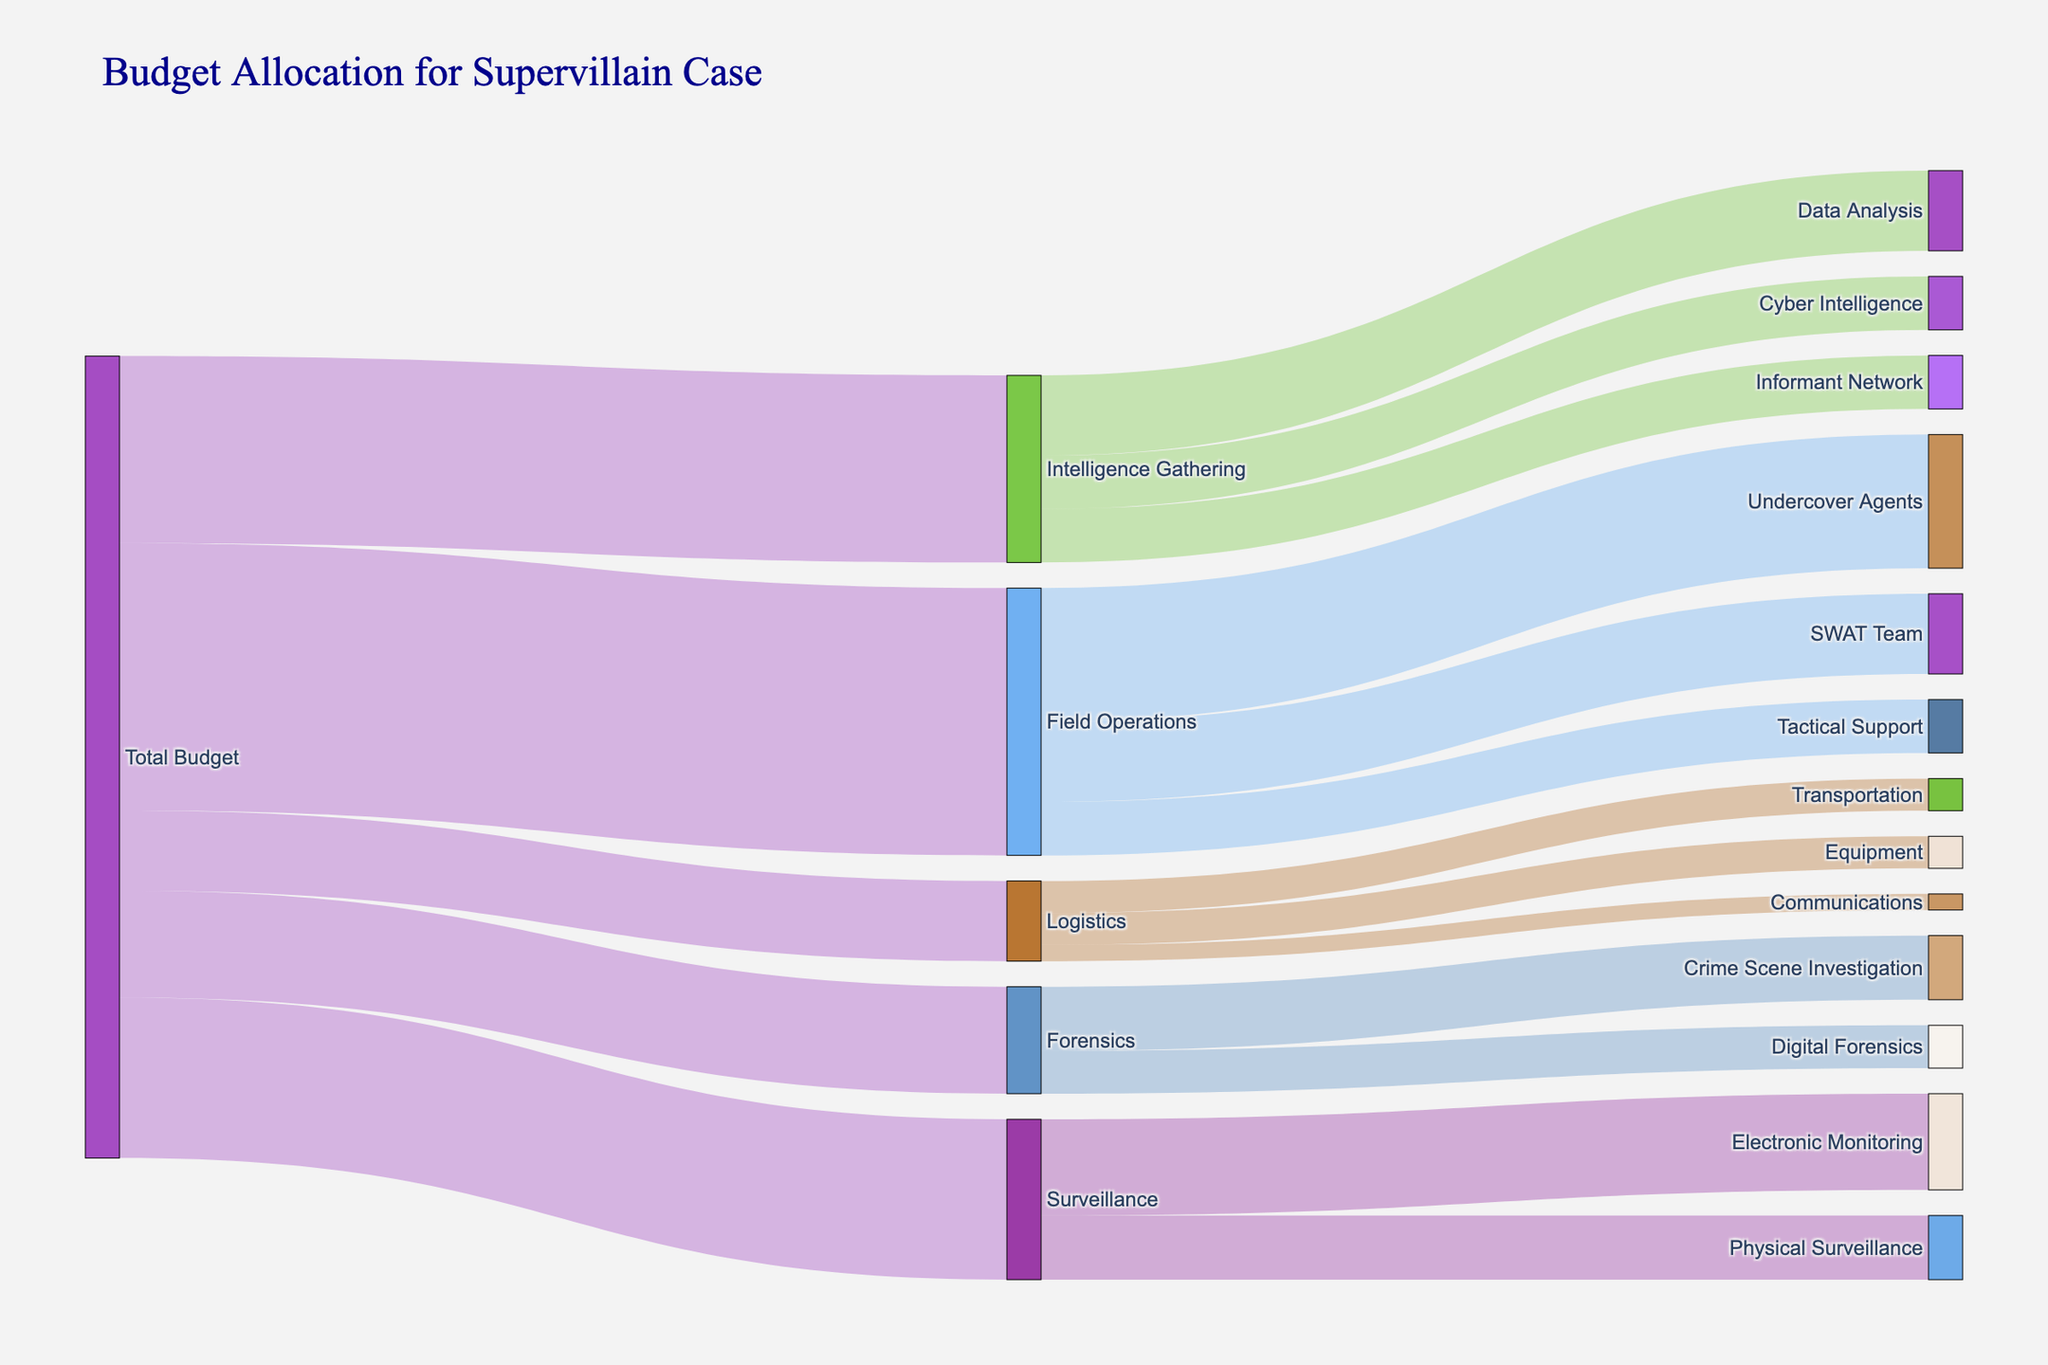What is the title of the Sankey diagram? The title is usually displayed at the top of the figure. According to the code, the title of this Sankey diagram is "Budget Allocation for Supervillain Case".
Answer: Budget Allocation for Supervillain Case What is the total budget allocated to Surveillance? Surveillance is one of the primary target categories originating from the Total Budget node. According to the data provided, Surveillance receives a direct allocation of $3,000,000.
Answer: 3,000,000 Which operation under Field Operations receives the highest budget allocation? Field Operations branches into three categories: Undercover Agents, SWAT Team, and Tactical Support. Comparing their allocations, Undercover Agents receive $2,500,000, which is higher than the other two.
Answer: Undercover Agents How much total budget is allocated to all Forensics-related activities? According to the data, Forensics encompasses Crime Scene Investigation and Digital Forensics. Summing their allocations: $1,200,000 + $800,000, the total budget for Forensics-related activities is $2,000,000.
Answer: 2,000,000 Which unit receives more funding, Cyber Intelligence or Electronic Monitoring? Cyber Intelligence is under Intelligence Gathering and Electronic Monitoring is under Surveillance. Cyber Intelligence receives $1,000,000 while Electronic Monitoring receives $1,800,000. Thus, Electronic Monitoring receives more funding.
Answer: Electronic Monitoring What is the combined budget allocation for both categories under Logistics? Logistics includes Transportation, Equipment, and Communications. Their allocations are $600,000, $600,000, and $300,000 respectively. Summing these allocations gives: $600,000 + $600,000 + $300,000 = $1,500,000.
Answer: 1,500,000 How does the budget allocation for Informant Network compare to that for Crime Scene Investigation? Informant Network under Intelligence Gathering is allocated $1,000,000. In contrast, Crime Scene Investigation under Forensics is allocated $1,200,000. Thus, Crime Scene Investigation receives more funding.
Answer: Crime Scene Investigation What fraction of the total budget is allocated to Intelligence Gathering? The total budget is the sum of all initial allocations: $5,000,000 (Field Operations) + $3,500,000 (Intelligence Gathering) + $2,000,000 (Forensics) + $3,000,000 (Surveillance) + $1,500,000 (Logistics) = $15,000,000. Therefore, Intelligence Gathering’s allocation fraction is $3,500,000 / $15,000,000 = 7/30 ≈ 0.233.
Answer: 0.233 Which department receives the least amount of funding? Examining the detailed budget allocations, Communications under Logistics receives the least funding with $300,000.
Answer: Communications 